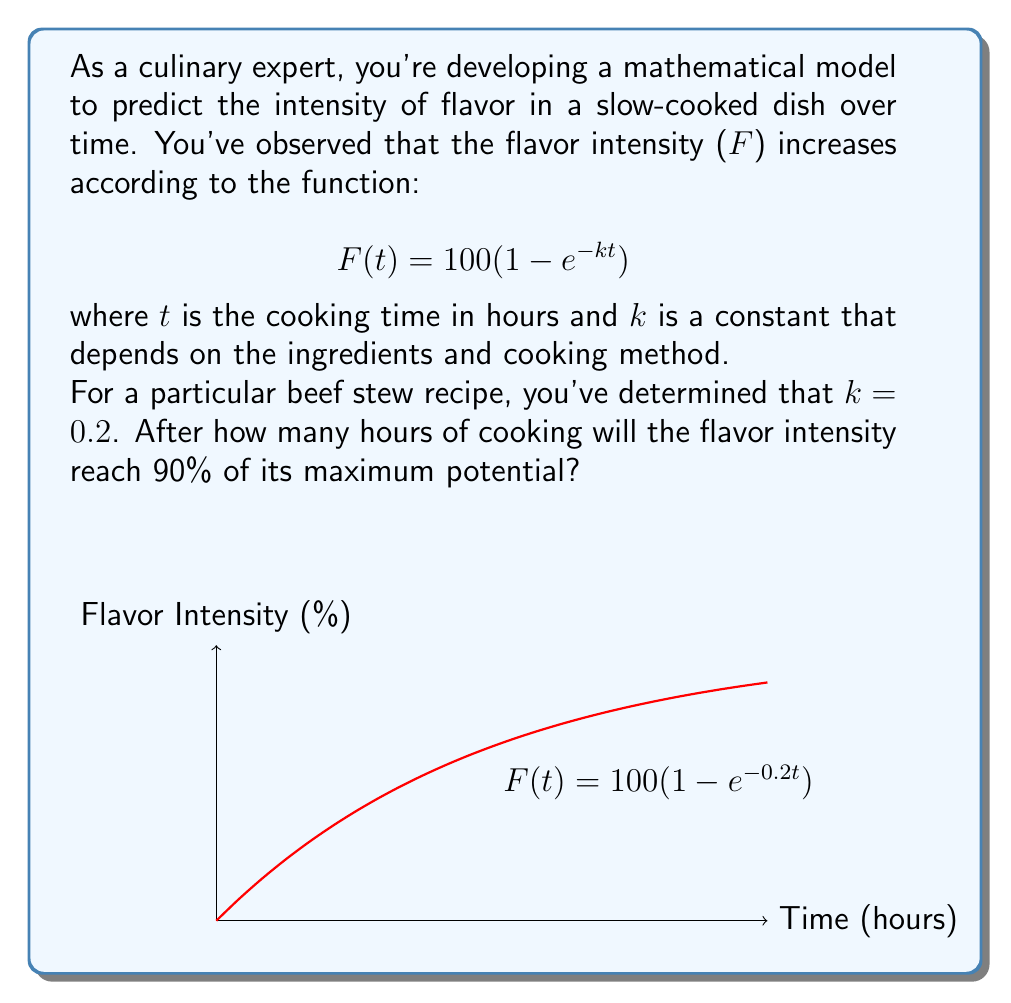Teach me how to tackle this problem. Let's approach this step-by-step:

1) We want to find t when F(t) is 90% of its maximum. The maximum flavor intensity is 100 (when t approaches infinity).

2) So, we need to solve the equation:
   $$90 = 100(1 - e^{-0.2t})$$

3) Dividing both sides by 100:
   $$0.9 = 1 - e^{-0.2t}$$

4) Subtracting both sides from 1:
   $$0.1 = e^{-0.2t}$$

5) Taking the natural log of both sides:
   $$\ln(0.1) = -0.2t$$

6) Dividing both sides by -0.2:
   $$\frac{\ln(0.1)}{-0.2} = t$$

7) Calculate:
   $$t = \frac{\ln(0.1)}{-0.2} \approx 11.51$$

Therefore, it will take approximately 11.51 hours for the flavor intensity to reach 90% of its maximum potential.
Answer: 11.51 hours 